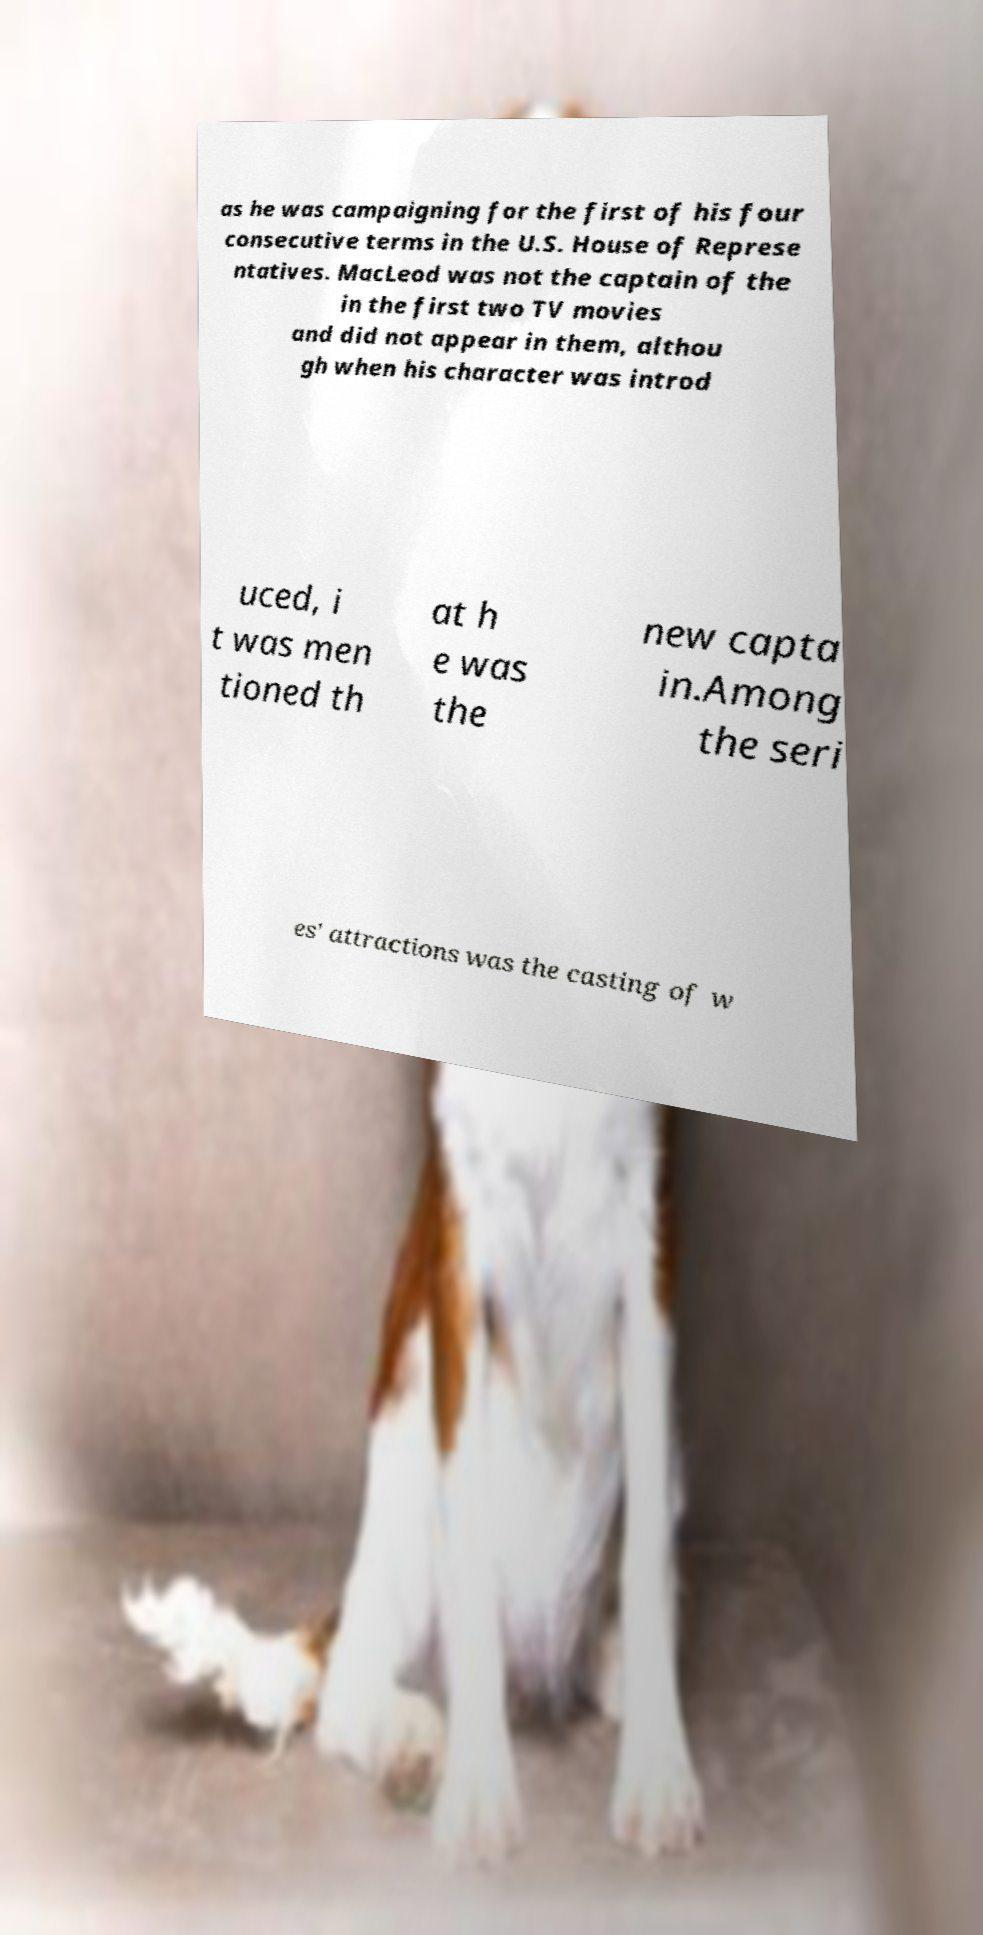Could you assist in decoding the text presented in this image and type it out clearly? as he was campaigning for the first of his four consecutive terms in the U.S. House of Represe ntatives. MacLeod was not the captain of the in the first two TV movies and did not appear in them, althou gh when his character was introd uced, i t was men tioned th at h e was the new capta in.Among the seri es' attractions was the casting of w 